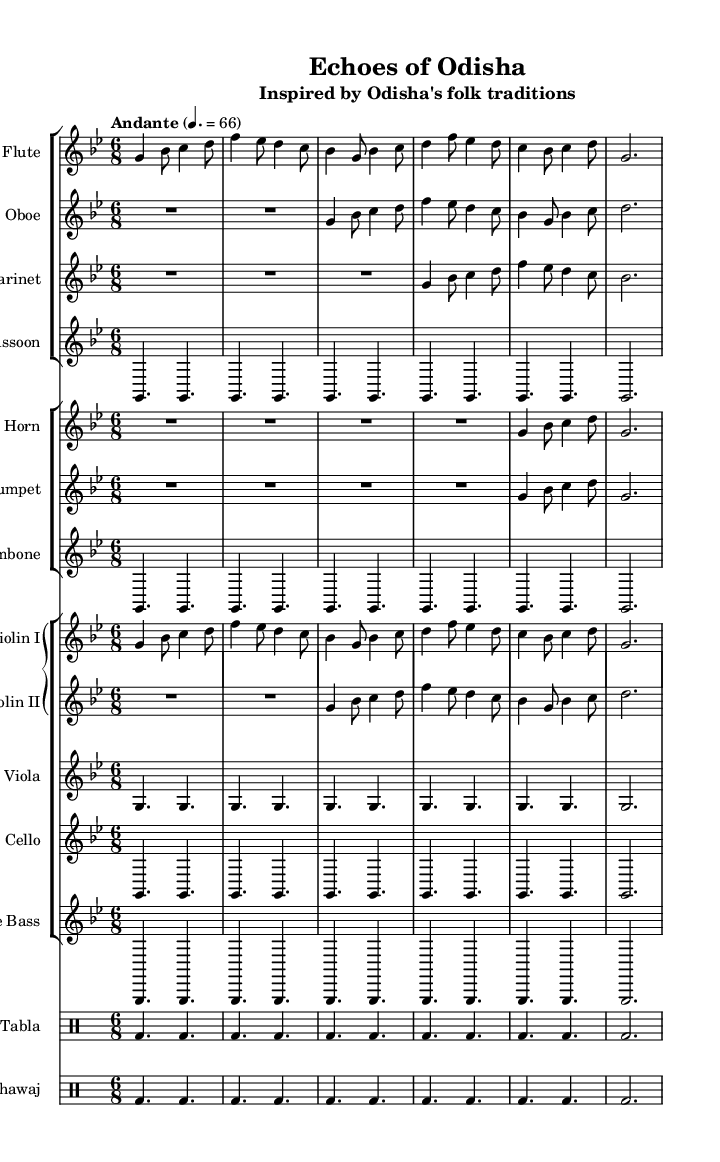What is the key signature of this music? The key signature appears to be G minor, as indicated by the two flats in the key signature at the beginning of the sheet music.
Answer: G minor What is the time signature of this symphony? The time signature is indicated on the first line of the sheet music, which shows a 6/8 time signature, meaning there are six eighth notes per measure.
Answer: 6/8 What tempo is indicated for this piece? The tempo marking appears at the beginning of the score and states "Andante," which translates to a moderately slow tempo, with the metronome marking of 4 beats per minute being 66.
Answer: Andante How many instruments are listed in this symphony? By counting all the instrumental groups in the score, there are a total of seven different instruments or groups mentioned, including woodwinds, brass, strings, and percussion.
Answer: Seven Which percussion instruments are included in this composition? The percussion section consists of two instruments: the tabla and the pakhawaj, which are traditional Indian percussion instruments used in folk music of Odisha.
Answer: Tabla and Pakhawaj What is the relationship between the flute and violin I parts in this symphony? The flute and violin I parts share a melodic similarity, as both instruments play similar patterns and motifs throughout the score, creating a harmonious texture typical of symphonic music.
Answer: Melodic similarity What is the primary mood conveyed by the symphonic interpretation of Odisha's folk melodies? The overall mood of the symphonic piece reflects a blend of nostalgia and celebration, often found in folk traditions, achieved through the rhythmic and melodic structures presented.
Answer: Nostalgia and celebration 